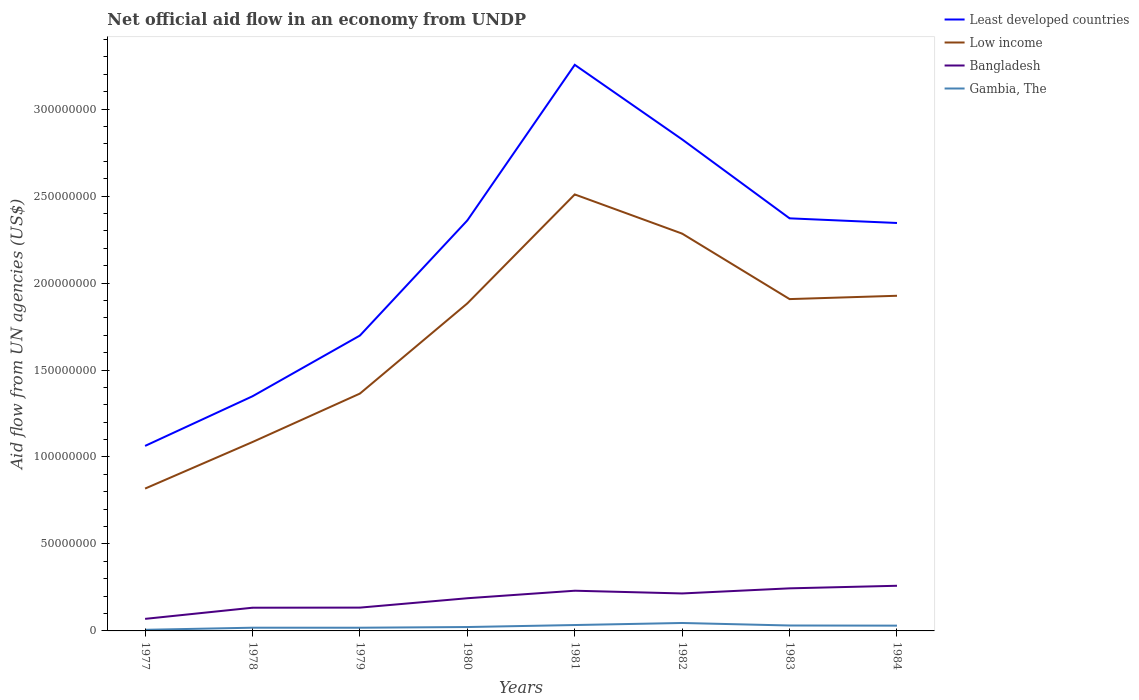Across all years, what is the maximum net official aid flow in Least developed countries?
Make the answer very short. 1.06e+08. What is the total net official aid flow in Least developed countries in the graph?
Ensure brevity in your answer.  -9.96e+07. What is the difference between the highest and the second highest net official aid flow in Gambia, The?
Offer a terse response. 3.92e+06. How many lines are there?
Keep it short and to the point. 4. Are the values on the major ticks of Y-axis written in scientific E-notation?
Your answer should be very brief. No. Does the graph contain grids?
Make the answer very short. No. What is the title of the graph?
Provide a short and direct response. Net official aid flow in an economy from UNDP. What is the label or title of the Y-axis?
Your answer should be compact. Aid flow from UN agencies (US$). What is the Aid flow from UN agencies (US$) in Least developed countries in 1977?
Ensure brevity in your answer.  1.06e+08. What is the Aid flow from UN agencies (US$) of Low income in 1977?
Offer a terse response. 8.18e+07. What is the Aid flow from UN agencies (US$) of Bangladesh in 1977?
Keep it short and to the point. 6.93e+06. What is the Aid flow from UN agencies (US$) of Gambia, The in 1977?
Your response must be concise. 6.40e+05. What is the Aid flow from UN agencies (US$) in Least developed countries in 1978?
Make the answer very short. 1.35e+08. What is the Aid flow from UN agencies (US$) of Low income in 1978?
Provide a short and direct response. 1.09e+08. What is the Aid flow from UN agencies (US$) in Bangladesh in 1978?
Your answer should be very brief. 1.33e+07. What is the Aid flow from UN agencies (US$) of Gambia, The in 1978?
Ensure brevity in your answer.  1.85e+06. What is the Aid flow from UN agencies (US$) in Least developed countries in 1979?
Offer a very short reply. 1.70e+08. What is the Aid flow from UN agencies (US$) of Low income in 1979?
Provide a short and direct response. 1.36e+08. What is the Aid flow from UN agencies (US$) in Bangladesh in 1979?
Your answer should be very brief. 1.34e+07. What is the Aid flow from UN agencies (US$) in Gambia, The in 1979?
Make the answer very short. 1.84e+06. What is the Aid flow from UN agencies (US$) in Least developed countries in 1980?
Provide a succinct answer. 2.36e+08. What is the Aid flow from UN agencies (US$) in Low income in 1980?
Your answer should be compact. 1.88e+08. What is the Aid flow from UN agencies (US$) of Bangladesh in 1980?
Give a very brief answer. 1.88e+07. What is the Aid flow from UN agencies (US$) in Gambia, The in 1980?
Your answer should be compact. 2.24e+06. What is the Aid flow from UN agencies (US$) of Least developed countries in 1981?
Keep it short and to the point. 3.25e+08. What is the Aid flow from UN agencies (US$) in Low income in 1981?
Your answer should be compact. 2.51e+08. What is the Aid flow from UN agencies (US$) of Bangladesh in 1981?
Make the answer very short. 2.31e+07. What is the Aid flow from UN agencies (US$) in Gambia, The in 1981?
Provide a succinct answer. 3.39e+06. What is the Aid flow from UN agencies (US$) of Least developed countries in 1982?
Keep it short and to the point. 2.83e+08. What is the Aid flow from UN agencies (US$) in Low income in 1982?
Offer a terse response. 2.28e+08. What is the Aid flow from UN agencies (US$) of Bangladesh in 1982?
Provide a succinct answer. 2.15e+07. What is the Aid flow from UN agencies (US$) of Gambia, The in 1982?
Make the answer very short. 4.56e+06. What is the Aid flow from UN agencies (US$) of Least developed countries in 1983?
Make the answer very short. 2.37e+08. What is the Aid flow from UN agencies (US$) in Low income in 1983?
Your answer should be compact. 1.91e+08. What is the Aid flow from UN agencies (US$) in Bangladesh in 1983?
Your answer should be very brief. 2.45e+07. What is the Aid flow from UN agencies (US$) of Gambia, The in 1983?
Keep it short and to the point. 3.12e+06. What is the Aid flow from UN agencies (US$) of Least developed countries in 1984?
Offer a terse response. 2.35e+08. What is the Aid flow from UN agencies (US$) in Low income in 1984?
Ensure brevity in your answer.  1.93e+08. What is the Aid flow from UN agencies (US$) of Bangladesh in 1984?
Your response must be concise. 2.60e+07. What is the Aid flow from UN agencies (US$) of Gambia, The in 1984?
Your response must be concise. 3.04e+06. Across all years, what is the maximum Aid flow from UN agencies (US$) of Least developed countries?
Offer a very short reply. 3.25e+08. Across all years, what is the maximum Aid flow from UN agencies (US$) in Low income?
Keep it short and to the point. 2.51e+08. Across all years, what is the maximum Aid flow from UN agencies (US$) in Bangladesh?
Give a very brief answer. 2.60e+07. Across all years, what is the maximum Aid flow from UN agencies (US$) of Gambia, The?
Ensure brevity in your answer.  4.56e+06. Across all years, what is the minimum Aid flow from UN agencies (US$) in Least developed countries?
Provide a short and direct response. 1.06e+08. Across all years, what is the minimum Aid flow from UN agencies (US$) in Low income?
Keep it short and to the point. 8.18e+07. Across all years, what is the minimum Aid flow from UN agencies (US$) of Bangladesh?
Offer a terse response. 6.93e+06. Across all years, what is the minimum Aid flow from UN agencies (US$) of Gambia, The?
Provide a succinct answer. 6.40e+05. What is the total Aid flow from UN agencies (US$) in Least developed countries in the graph?
Give a very brief answer. 1.73e+09. What is the total Aid flow from UN agencies (US$) in Low income in the graph?
Your answer should be compact. 1.38e+09. What is the total Aid flow from UN agencies (US$) of Bangladesh in the graph?
Your answer should be very brief. 1.48e+08. What is the total Aid flow from UN agencies (US$) of Gambia, The in the graph?
Keep it short and to the point. 2.07e+07. What is the difference between the Aid flow from UN agencies (US$) in Least developed countries in 1977 and that in 1978?
Make the answer very short. -2.85e+07. What is the difference between the Aid flow from UN agencies (US$) in Low income in 1977 and that in 1978?
Offer a terse response. -2.68e+07. What is the difference between the Aid flow from UN agencies (US$) in Bangladesh in 1977 and that in 1978?
Provide a short and direct response. -6.41e+06. What is the difference between the Aid flow from UN agencies (US$) in Gambia, The in 1977 and that in 1978?
Provide a succinct answer. -1.21e+06. What is the difference between the Aid flow from UN agencies (US$) of Least developed countries in 1977 and that in 1979?
Keep it short and to the point. -6.34e+07. What is the difference between the Aid flow from UN agencies (US$) in Low income in 1977 and that in 1979?
Provide a short and direct response. -5.46e+07. What is the difference between the Aid flow from UN agencies (US$) in Bangladesh in 1977 and that in 1979?
Give a very brief answer. -6.47e+06. What is the difference between the Aid flow from UN agencies (US$) in Gambia, The in 1977 and that in 1979?
Give a very brief answer. -1.20e+06. What is the difference between the Aid flow from UN agencies (US$) of Least developed countries in 1977 and that in 1980?
Your response must be concise. -1.30e+08. What is the difference between the Aid flow from UN agencies (US$) in Low income in 1977 and that in 1980?
Give a very brief answer. -1.06e+08. What is the difference between the Aid flow from UN agencies (US$) of Bangladesh in 1977 and that in 1980?
Keep it short and to the point. -1.19e+07. What is the difference between the Aid flow from UN agencies (US$) in Gambia, The in 1977 and that in 1980?
Provide a succinct answer. -1.60e+06. What is the difference between the Aid flow from UN agencies (US$) of Least developed countries in 1977 and that in 1981?
Provide a succinct answer. -2.19e+08. What is the difference between the Aid flow from UN agencies (US$) in Low income in 1977 and that in 1981?
Make the answer very short. -1.69e+08. What is the difference between the Aid flow from UN agencies (US$) of Bangladesh in 1977 and that in 1981?
Your answer should be compact. -1.62e+07. What is the difference between the Aid flow from UN agencies (US$) in Gambia, The in 1977 and that in 1981?
Ensure brevity in your answer.  -2.75e+06. What is the difference between the Aid flow from UN agencies (US$) in Least developed countries in 1977 and that in 1982?
Provide a succinct answer. -1.76e+08. What is the difference between the Aid flow from UN agencies (US$) in Low income in 1977 and that in 1982?
Offer a very short reply. -1.47e+08. What is the difference between the Aid flow from UN agencies (US$) in Bangladesh in 1977 and that in 1982?
Offer a very short reply. -1.46e+07. What is the difference between the Aid flow from UN agencies (US$) in Gambia, The in 1977 and that in 1982?
Offer a very short reply. -3.92e+06. What is the difference between the Aid flow from UN agencies (US$) of Least developed countries in 1977 and that in 1983?
Provide a short and direct response. -1.31e+08. What is the difference between the Aid flow from UN agencies (US$) of Low income in 1977 and that in 1983?
Provide a short and direct response. -1.09e+08. What is the difference between the Aid flow from UN agencies (US$) of Bangladesh in 1977 and that in 1983?
Keep it short and to the point. -1.76e+07. What is the difference between the Aid flow from UN agencies (US$) in Gambia, The in 1977 and that in 1983?
Give a very brief answer. -2.48e+06. What is the difference between the Aid flow from UN agencies (US$) in Least developed countries in 1977 and that in 1984?
Make the answer very short. -1.28e+08. What is the difference between the Aid flow from UN agencies (US$) of Low income in 1977 and that in 1984?
Provide a short and direct response. -1.11e+08. What is the difference between the Aid flow from UN agencies (US$) in Bangladesh in 1977 and that in 1984?
Your response must be concise. -1.90e+07. What is the difference between the Aid flow from UN agencies (US$) of Gambia, The in 1977 and that in 1984?
Offer a very short reply. -2.40e+06. What is the difference between the Aid flow from UN agencies (US$) in Least developed countries in 1978 and that in 1979?
Provide a short and direct response. -3.49e+07. What is the difference between the Aid flow from UN agencies (US$) in Low income in 1978 and that in 1979?
Give a very brief answer. -2.78e+07. What is the difference between the Aid flow from UN agencies (US$) of Least developed countries in 1978 and that in 1980?
Ensure brevity in your answer.  -1.01e+08. What is the difference between the Aid flow from UN agencies (US$) of Low income in 1978 and that in 1980?
Provide a succinct answer. -7.97e+07. What is the difference between the Aid flow from UN agencies (US$) of Bangladesh in 1978 and that in 1980?
Give a very brief answer. -5.45e+06. What is the difference between the Aid flow from UN agencies (US$) of Gambia, The in 1978 and that in 1980?
Provide a succinct answer. -3.90e+05. What is the difference between the Aid flow from UN agencies (US$) of Least developed countries in 1978 and that in 1981?
Provide a short and direct response. -1.91e+08. What is the difference between the Aid flow from UN agencies (US$) of Low income in 1978 and that in 1981?
Keep it short and to the point. -1.42e+08. What is the difference between the Aid flow from UN agencies (US$) in Bangladesh in 1978 and that in 1981?
Give a very brief answer. -9.77e+06. What is the difference between the Aid flow from UN agencies (US$) in Gambia, The in 1978 and that in 1981?
Ensure brevity in your answer.  -1.54e+06. What is the difference between the Aid flow from UN agencies (US$) in Least developed countries in 1978 and that in 1982?
Ensure brevity in your answer.  -1.48e+08. What is the difference between the Aid flow from UN agencies (US$) in Low income in 1978 and that in 1982?
Offer a very short reply. -1.20e+08. What is the difference between the Aid flow from UN agencies (US$) of Bangladesh in 1978 and that in 1982?
Offer a very short reply. -8.20e+06. What is the difference between the Aid flow from UN agencies (US$) of Gambia, The in 1978 and that in 1982?
Your answer should be very brief. -2.71e+06. What is the difference between the Aid flow from UN agencies (US$) in Least developed countries in 1978 and that in 1983?
Your answer should be compact. -1.02e+08. What is the difference between the Aid flow from UN agencies (US$) in Low income in 1978 and that in 1983?
Provide a short and direct response. -8.22e+07. What is the difference between the Aid flow from UN agencies (US$) of Bangladesh in 1978 and that in 1983?
Make the answer very short. -1.11e+07. What is the difference between the Aid flow from UN agencies (US$) of Gambia, The in 1978 and that in 1983?
Give a very brief answer. -1.27e+06. What is the difference between the Aid flow from UN agencies (US$) of Least developed countries in 1978 and that in 1984?
Make the answer very short. -9.96e+07. What is the difference between the Aid flow from UN agencies (US$) in Low income in 1978 and that in 1984?
Make the answer very short. -8.41e+07. What is the difference between the Aid flow from UN agencies (US$) in Bangladesh in 1978 and that in 1984?
Your answer should be compact. -1.26e+07. What is the difference between the Aid flow from UN agencies (US$) of Gambia, The in 1978 and that in 1984?
Your answer should be very brief. -1.19e+06. What is the difference between the Aid flow from UN agencies (US$) of Least developed countries in 1979 and that in 1980?
Your answer should be very brief. -6.62e+07. What is the difference between the Aid flow from UN agencies (US$) in Low income in 1979 and that in 1980?
Give a very brief answer. -5.18e+07. What is the difference between the Aid flow from UN agencies (US$) in Bangladesh in 1979 and that in 1980?
Make the answer very short. -5.39e+06. What is the difference between the Aid flow from UN agencies (US$) of Gambia, The in 1979 and that in 1980?
Offer a very short reply. -4.00e+05. What is the difference between the Aid flow from UN agencies (US$) in Least developed countries in 1979 and that in 1981?
Your answer should be very brief. -1.56e+08. What is the difference between the Aid flow from UN agencies (US$) in Low income in 1979 and that in 1981?
Keep it short and to the point. -1.14e+08. What is the difference between the Aid flow from UN agencies (US$) of Bangladesh in 1979 and that in 1981?
Make the answer very short. -9.71e+06. What is the difference between the Aid flow from UN agencies (US$) in Gambia, The in 1979 and that in 1981?
Offer a terse response. -1.55e+06. What is the difference between the Aid flow from UN agencies (US$) of Least developed countries in 1979 and that in 1982?
Your answer should be very brief. -1.13e+08. What is the difference between the Aid flow from UN agencies (US$) of Low income in 1979 and that in 1982?
Provide a succinct answer. -9.20e+07. What is the difference between the Aid flow from UN agencies (US$) in Bangladesh in 1979 and that in 1982?
Your answer should be compact. -8.14e+06. What is the difference between the Aid flow from UN agencies (US$) of Gambia, The in 1979 and that in 1982?
Ensure brevity in your answer.  -2.72e+06. What is the difference between the Aid flow from UN agencies (US$) in Least developed countries in 1979 and that in 1983?
Make the answer very short. -6.74e+07. What is the difference between the Aid flow from UN agencies (US$) of Low income in 1979 and that in 1983?
Make the answer very short. -5.43e+07. What is the difference between the Aid flow from UN agencies (US$) of Bangladesh in 1979 and that in 1983?
Ensure brevity in your answer.  -1.11e+07. What is the difference between the Aid flow from UN agencies (US$) in Gambia, The in 1979 and that in 1983?
Ensure brevity in your answer.  -1.28e+06. What is the difference between the Aid flow from UN agencies (US$) in Least developed countries in 1979 and that in 1984?
Your answer should be compact. -6.47e+07. What is the difference between the Aid flow from UN agencies (US$) in Low income in 1979 and that in 1984?
Provide a short and direct response. -5.62e+07. What is the difference between the Aid flow from UN agencies (US$) of Bangladesh in 1979 and that in 1984?
Offer a terse response. -1.26e+07. What is the difference between the Aid flow from UN agencies (US$) of Gambia, The in 1979 and that in 1984?
Offer a terse response. -1.20e+06. What is the difference between the Aid flow from UN agencies (US$) of Least developed countries in 1980 and that in 1981?
Offer a terse response. -8.95e+07. What is the difference between the Aid flow from UN agencies (US$) in Low income in 1980 and that in 1981?
Your answer should be very brief. -6.26e+07. What is the difference between the Aid flow from UN agencies (US$) in Bangladesh in 1980 and that in 1981?
Your answer should be compact. -4.32e+06. What is the difference between the Aid flow from UN agencies (US$) of Gambia, The in 1980 and that in 1981?
Provide a succinct answer. -1.15e+06. What is the difference between the Aid flow from UN agencies (US$) of Least developed countries in 1980 and that in 1982?
Make the answer very short. -4.66e+07. What is the difference between the Aid flow from UN agencies (US$) of Low income in 1980 and that in 1982?
Offer a terse response. -4.01e+07. What is the difference between the Aid flow from UN agencies (US$) of Bangladesh in 1980 and that in 1982?
Make the answer very short. -2.75e+06. What is the difference between the Aid flow from UN agencies (US$) of Gambia, The in 1980 and that in 1982?
Keep it short and to the point. -2.32e+06. What is the difference between the Aid flow from UN agencies (US$) of Least developed countries in 1980 and that in 1983?
Ensure brevity in your answer.  -1.20e+06. What is the difference between the Aid flow from UN agencies (US$) in Low income in 1980 and that in 1983?
Ensure brevity in your answer.  -2.47e+06. What is the difference between the Aid flow from UN agencies (US$) of Bangladesh in 1980 and that in 1983?
Your answer should be very brief. -5.69e+06. What is the difference between the Aid flow from UN agencies (US$) in Gambia, The in 1980 and that in 1983?
Your response must be concise. -8.80e+05. What is the difference between the Aid flow from UN agencies (US$) in Least developed countries in 1980 and that in 1984?
Offer a terse response. 1.47e+06. What is the difference between the Aid flow from UN agencies (US$) in Low income in 1980 and that in 1984?
Your response must be concise. -4.38e+06. What is the difference between the Aid flow from UN agencies (US$) in Bangladesh in 1980 and that in 1984?
Offer a very short reply. -7.17e+06. What is the difference between the Aid flow from UN agencies (US$) in Gambia, The in 1980 and that in 1984?
Your answer should be very brief. -8.00e+05. What is the difference between the Aid flow from UN agencies (US$) of Least developed countries in 1981 and that in 1982?
Provide a succinct answer. 4.29e+07. What is the difference between the Aid flow from UN agencies (US$) in Low income in 1981 and that in 1982?
Keep it short and to the point. 2.25e+07. What is the difference between the Aid flow from UN agencies (US$) in Bangladesh in 1981 and that in 1982?
Provide a succinct answer. 1.57e+06. What is the difference between the Aid flow from UN agencies (US$) in Gambia, The in 1981 and that in 1982?
Offer a very short reply. -1.17e+06. What is the difference between the Aid flow from UN agencies (US$) in Least developed countries in 1981 and that in 1983?
Provide a succinct answer. 8.83e+07. What is the difference between the Aid flow from UN agencies (US$) of Low income in 1981 and that in 1983?
Your response must be concise. 6.02e+07. What is the difference between the Aid flow from UN agencies (US$) in Bangladesh in 1981 and that in 1983?
Offer a terse response. -1.37e+06. What is the difference between the Aid flow from UN agencies (US$) of Gambia, The in 1981 and that in 1983?
Keep it short and to the point. 2.70e+05. What is the difference between the Aid flow from UN agencies (US$) of Least developed countries in 1981 and that in 1984?
Your response must be concise. 9.09e+07. What is the difference between the Aid flow from UN agencies (US$) of Low income in 1981 and that in 1984?
Keep it short and to the point. 5.83e+07. What is the difference between the Aid flow from UN agencies (US$) in Bangladesh in 1981 and that in 1984?
Provide a short and direct response. -2.85e+06. What is the difference between the Aid flow from UN agencies (US$) of Gambia, The in 1981 and that in 1984?
Give a very brief answer. 3.50e+05. What is the difference between the Aid flow from UN agencies (US$) of Least developed countries in 1982 and that in 1983?
Offer a very short reply. 4.54e+07. What is the difference between the Aid flow from UN agencies (US$) of Low income in 1982 and that in 1983?
Make the answer very short. 3.76e+07. What is the difference between the Aid flow from UN agencies (US$) of Bangladesh in 1982 and that in 1983?
Make the answer very short. -2.94e+06. What is the difference between the Aid flow from UN agencies (US$) of Gambia, The in 1982 and that in 1983?
Your answer should be very brief. 1.44e+06. What is the difference between the Aid flow from UN agencies (US$) of Least developed countries in 1982 and that in 1984?
Your answer should be compact. 4.80e+07. What is the difference between the Aid flow from UN agencies (US$) in Low income in 1982 and that in 1984?
Keep it short and to the point. 3.57e+07. What is the difference between the Aid flow from UN agencies (US$) in Bangladesh in 1982 and that in 1984?
Your answer should be very brief. -4.42e+06. What is the difference between the Aid flow from UN agencies (US$) of Gambia, The in 1982 and that in 1984?
Ensure brevity in your answer.  1.52e+06. What is the difference between the Aid flow from UN agencies (US$) in Least developed countries in 1983 and that in 1984?
Keep it short and to the point. 2.67e+06. What is the difference between the Aid flow from UN agencies (US$) in Low income in 1983 and that in 1984?
Give a very brief answer. -1.91e+06. What is the difference between the Aid flow from UN agencies (US$) of Bangladesh in 1983 and that in 1984?
Make the answer very short. -1.48e+06. What is the difference between the Aid flow from UN agencies (US$) of Least developed countries in 1977 and the Aid flow from UN agencies (US$) of Low income in 1978?
Your response must be concise. -2.24e+06. What is the difference between the Aid flow from UN agencies (US$) in Least developed countries in 1977 and the Aid flow from UN agencies (US$) in Bangladesh in 1978?
Offer a terse response. 9.30e+07. What is the difference between the Aid flow from UN agencies (US$) of Least developed countries in 1977 and the Aid flow from UN agencies (US$) of Gambia, The in 1978?
Offer a very short reply. 1.05e+08. What is the difference between the Aid flow from UN agencies (US$) in Low income in 1977 and the Aid flow from UN agencies (US$) in Bangladesh in 1978?
Offer a terse response. 6.85e+07. What is the difference between the Aid flow from UN agencies (US$) in Low income in 1977 and the Aid flow from UN agencies (US$) in Gambia, The in 1978?
Ensure brevity in your answer.  8.00e+07. What is the difference between the Aid flow from UN agencies (US$) of Bangladesh in 1977 and the Aid flow from UN agencies (US$) of Gambia, The in 1978?
Your response must be concise. 5.08e+06. What is the difference between the Aid flow from UN agencies (US$) of Least developed countries in 1977 and the Aid flow from UN agencies (US$) of Low income in 1979?
Give a very brief answer. -3.01e+07. What is the difference between the Aid flow from UN agencies (US$) in Least developed countries in 1977 and the Aid flow from UN agencies (US$) in Bangladesh in 1979?
Keep it short and to the point. 9.30e+07. What is the difference between the Aid flow from UN agencies (US$) in Least developed countries in 1977 and the Aid flow from UN agencies (US$) in Gambia, The in 1979?
Your answer should be compact. 1.05e+08. What is the difference between the Aid flow from UN agencies (US$) of Low income in 1977 and the Aid flow from UN agencies (US$) of Bangladesh in 1979?
Give a very brief answer. 6.84e+07. What is the difference between the Aid flow from UN agencies (US$) of Low income in 1977 and the Aid flow from UN agencies (US$) of Gambia, The in 1979?
Make the answer very short. 8.00e+07. What is the difference between the Aid flow from UN agencies (US$) in Bangladesh in 1977 and the Aid flow from UN agencies (US$) in Gambia, The in 1979?
Your answer should be very brief. 5.09e+06. What is the difference between the Aid flow from UN agencies (US$) of Least developed countries in 1977 and the Aid flow from UN agencies (US$) of Low income in 1980?
Your response must be concise. -8.19e+07. What is the difference between the Aid flow from UN agencies (US$) in Least developed countries in 1977 and the Aid flow from UN agencies (US$) in Bangladesh in 1980?
Offer a very short reply. 8.76e+07. What is the difference between the Aid flow from UN agencies (US$) in Least developed countries in 1977 and the Aid flow from UN agencies (US$) in Gambia, The in 1980?
Make the answer very short. 1.04e+08. What is the difference between the Aid flow from UN agencies (US$) of Low income in 1977 and the Aid flow from UN agencies (US$) of Bangladesh in 1980?
Give a very brief answer. 6.30e+07. What is the difference between the Aid flow from UN agencies (US$) of Low income in 1977 and the Aid flow from UN agencies (US$) of Gambia, The in 1980?
Give a very brief answer. 7.96e+07. What is the difference between the Aid flow from UN agencies (US$) of Bangladesh in 1977 and the Aid flow from UN agencies (US$) of Gambia, The in 1980?
Offer a very short reply. 4.69e+06. What is the difference between the Aid flow from UN agencies (US$) in Least developed countries in 1977 and the Aid flow from UN agencies (US$) in Low income in 1981?
Your answer should be very brief. -1.45e+08. What is the difference between the Aid flow from UN agencies (US$) in Least developed countries in 1977 and the Aid flow from UN agencies (US$) in Bangladesh in 1981?
Provide a short and direct response. 8.33e+07. What is the difference between the Aid flow from UN agencies (US$) in Least developed countries in 1977 and the Aid flow from UN agencies (US$) in Gambia, The in 1981?
Your response must be concise. 1.03e+08. What is the difference between the Aid flow from UN agencies (US$) in Low income in 1977 and the Aid flow from UN agencies (US$) in Bangladesh in 1981?
Ensure brevity in your answer.  5.87e+07. What is the difference between the Aid flow from UN agencies (US$) of Low income in 1977 and the Aid flow from UN agencies (US$) of Gambia, The in 1981?
Provide a short and direct response. 7.84e+07. What is the difference between the Aid flow from UN agencies (US$) of Bangladesh in 1977 and the Aid flow from UN agencies (US$) of Gambia, The in 1981?
Make the answer very short. 3.54e+06. What is the difference between the Aid flow from UN agencies (US$) in Least developed countries in 1977 and the Aid flow from UN agencies (US$) in Low income in 1982?
Offer a very short reply. -1.22e+08. What is the difference between the Aid flow from UN agencies (US$) in Least developed countries in 1977 and the Aid flow from UN agencies (US$) in Bangladesh in 1982?
Your answer should be compact. 8.48e+07. What is the difference between the Aid flow from UN agencies (US$) of Least developed countries in 1977 and the Aid flow from UN agencies (US$) of Gambia, The in 1982?
Keep it short and to the point. 1.02e+08. What is the difference between the Aid flow from UN agencies (US$) of Low income in 1977 and the Aid flow from UN agencies (US$) of Bangladesh in 1982?
Provide a short and direct response. 6.03e+07. What is the difference between the Aid flow from UN agencies (US$) in Low income in 1977 and the Aid flow from UN agencies (US$) in Gambia, The in 1982?
Ensure brevity in your answer.  7.73e+07. What is the difference between the Aid flow from UN agencies (US$) in Bangladesh in 1977 and the Aid flow from UN agencies (US$) in Gambia, The in 1982?
Offer a very short reply. 2.37e+06. What is the difference between the Aid flow from UN agencies (US$) of Least developed countries in 1977 and the Aid flow from UN agencies (US$) of Low income in 1983?
Your response must be concise. -8.44e+07. What is the difference between the Aid flow from UN agencies (US$) of Least developed countries in 1977 and the Aid flow from UN agencies (US$) of Bangladesh in 1983?
Offer a very short reply. 8.19e+07. What is the difference between the Aid flow from UN agencies (US$) in Least developed countries in 1977 and the Aid flow from UN agencies (US$) in Gambia, The in 1983?
Ensure brevity in your answer.  1.03e+08. What is the difference between the Aid flow from UN agencies (US$) in Low income in 1977 and the Aid flow from UN agencies (US$) in Bangladesh in 1983?
Offer a very short reply. 5.74e+07. What is the difference between the Aid flow from UN agencies (US$) in Low income in 1977 and the Aid flow from UN agencies (US$) in Gambia, The in 1983?
Offer a terse response. 7.87e+07. What is the difference between the Aid flow from UN agencies (US$) in Bangladesh in 1977 and the Aid flow from UN agencies (US$) in Gambia, The in 1983?
Your answer should be very brief. 3.81e+06. What is the difference between the Aid flow from UN agencies (US$) in Least developed countries in 1977 and the Aid flow from UN agencies (US$) in Low income in 1984?
Your answer should be very brief. -8.63e+07. What is the difference between the Aid flow from UN agencies (US$) of Least developed countries in 1977 and the Aid flow from UN agencies (US$) of Bangladesh in 1984?
Offer a very short reply. 8.04e+07. What is the difference between the Aid flow from UN agencies (US$) in Least developed countries in 1977 and the Aid flow from UN agencies (US$) in Gambia, The in 1984?
Make the answer very short. 1.03e+08. What is the difference between the Aid flow from UN agencies (US$) of Low income in 1977 and the Aid flow from UN agencies (US$) of Bangladesh in 1984?
Offer a very short reply. 5.59e+07. What is the difference between the Aid flow from UN agencies (US$) of Low income in 1977 and the Aid flow from UN agencies (US$) of Gambia, The in 1984?
Offer a terse response. 7.88e+07. What is the difference between the Aid flow from UN agencies (US$) in Bangladesh in 1977 and the Aid flow from UN agencies (US$) in Gambia, The in 1984?
Your answer should be very brief. 3.89e+06. What is the difference between the Aid flow from UN agencies (US$) of Least developed countries in 1978 and the Aid flow from UN agencies (US$) of Low income in 1979?
Your answer should be compact. -1.55e+06. What is the difference between the Aid flow from UN agencies (US$) in Least developed countries in 1978 and the Aid flow from UN agencies (US$) in Bangladesh in 1979?
Give a very brief answer. 1.22e+08. What is the difference between the Aid flow from UN agencies (US$) of Least developed countries in 1978 and the Aid flow from UN agencies (US$) of Gambia, The in 1979?
Provide a short and direct response. 1.33e+08. What is the difference between the Aid flow from UN agencies (US$) in Low income in 1978 and the Aid flow from UN agencies (US$) in Bangladesh in 1979?
Provide a succinct answer. 9.52e+07. What is the difference between the Aid flow from UN agencies (US$) of Low income in 1978 and the Aid flow from UN agencies (US$) of Gambia, The in 1979?
Ensure brevity in your answer.  1.07e+08. What is the difference between the Aid flow from UN agencies (US$) of Bangladesh in 1978 and the Aid flow from UN agencies (US$) of Gambia, The in 1979?
Offer a very short reply. 1.15e+07. What is the difference between the Aid flow from UN agencies (US$) of Least developed countries in 1978 and the Aid flow from UN agencies (US$) of Low income in 1980?
Give a very brief answer. -5.34e+07. What is the difference between the Aid flow from UN agencies (US$) in Least developed countries in 1978 and the Aid flow from UN agencies (US$) in Bangladesh in 1980?
Your answer should be compact. 1.16e+08. What is the difference between the Aid flow from UN agencies (US$) in Least developed countries in 1978 and the Aid flow from UN agencies (US$) in Gambia, The in 1980?
Make the answer very short. 1.33e+08. What is the difference between the Aid flow from UN agencies (US$) of Low income in 1978 and the Aid flow from UN agencies (US$) of Bangladesh in 1980?
Give a very brief answer. 8.98e+07. What is the difference between the Aid flow from UN agencies (US$) of Low income in 1978 and the Aid flow from UN agencies (US$) of Gambia, The in 1980?
Your response must be concise. 1.06e+08. What is the difference between the Aid flow from UN agencies (US$) of Bangladesh in 1978 and the Aid flow from UN agencies (US$) of Gambia, The in 1980?
Your answer should be compact. 1.11e+07. What is the difference between the Aid flow from UN agencies (US$) of Least developed countries in 1978 and the Aid flow from UN agencies (US$) of Low income in 1981?
Offer a very short reply. -1.16e+08. What is the difference between the Aid flow from UN agencies (US$) of Least developed countries in 1978 and the Aid flow from UN agencies (US$) of Bangladesh in 1981?
Offer a terse response. 1.12e+08. What is the difference between the Aid flow from UN agencies (US$) of Least developed countries in 1978 and the Aid flow from UN agencies (US$) of Gambia, The in 1981?
Your answer should be very brief. 1.32e+08. What is the difference between the Aid flow from UN agencies (US$) of Low income in 1978 and the Aid flow from UN agencies (US$) of Bangladesh in 1981?
Make the answer very short. 8.55e+07. What is the difference between the Aid flow from UN agencies (US$) of Low income in 1978 and the Aid flow from UN agencies (US$) of Gambia, The in 1981?
Your answer should be compact. 1.05e+08. What is the difference between the Aid flow from UN agencies (US$) in Bangladesh in 1978 and the Aid flow from UN agencies (US$) in Gambia, The in 1981?
Ensure brevity in your answer.  9.95e+06. What is the difference between the Aid flow from UN agencies (US$) in Least developed countries in 1978 and the Aid flow from UN agencies (US$) in Low income in 1982?
Ensure brevity in your answer.  -9.35e+07. What is the difference between the Aid flow from UN agencies (US$) of Least developed countries in 1978 and the Aid flow from UN agencies (US$) of Bangladesh in 1982?
Offer a very short reply. 1.13e+08. What is the difference between the Aid flow from UN agencies (US$) of Least developed countries in 1978 and the Aid flow from UN agencies (US$) of Gambia, The in 1982?
Provide a succinct answer. 1.30e+08. What is the difference between the Aid flow from UN agencies (US$) in Low income in 1978 and the Aid flow from UN agencies (US$) in Bangladesh in 1982?
Your response must be concise. 8.71e+07. What is the difference between the Aid flow from UN agencies (US$) of Low income in 1978 and the Aid flow from UN agencies (US$) of Gambia, The in 1982?
Offer a terse response. 1.04e+08. What is the difference between the Aid flow from UN agencies (US$) in Bangladesh in 1978 and the Aid flow from UN agencies (US$) in Gambia, The in 1982?
Provide a short and direct response. 8.78e+06. What is the difference between the Aid flow from UN agencies (US$) of Least developed countries in 1978 and the Aid flow from UN agencies (US$) of Low income in 1983?
Provide a succinct answer. -5.59e+07. What is the difference between the Aid flow from UN agencies (US$) of Least developed countries in 1978 and the Aid flow from UN agencies (US$) of Bangladesh in 1983?
Offer a very short reply. 1.10e+08. What is the difference between the Aid flow from UN agencies (US$) in Least developed countries in 1978 and the Aid flow from UN agencies (US$) in Gambia, The in 1983?
Your answer should be very brief. 1.32e+08. What is the difference between the Aid flow from UN agencies (US$) of Low income in 1978 and the Aid flow from UN agencies (US$) of Bangladesh in 1983?
Keep it short and to the point. 8.41e+07. What is the difference between the Aid flow from UN agencies (US$) of Low income in 1978 and the Aid flow from UN agencies (US$) of Gambia, The in 1983?
Provide a succinct answer. 1.05e+08. What is the difference between the Aid flow from UN agencies (US$) of Bangladesh in 1978 and the Aid flow from UN agencies (US$) of Gambia, The in 1983?
Offer a very short reply. 1.02e+07. What is the difference between the Aid flow from UN agencies (US$) in Least developed countries in 1978 and the Aid flow from UN agencies (US$) in Low income in 1984?
Keep it short and to the point. -5.78e+07. What is the difference between the Aid flow from UN agencies (US$) in Least developed countries in 1978 and the Aid flow from UN agencies (US$) in Bangladesh in 1984?
Provide a short and direct response. 1.09e+08. What is the difference between the Aid flow from UN agencies (US$) in Least developed countries in 1978 and the Aid flow from UN agencies (US$) in Gambia, The in 1984?
Your answer should be very brief. 1.32e+08. What is the difference between the Aid flow from UN agencies (US$) in Low income in 1978 and the Aid flow from UN agencies (US$) in Bangladesh in 1984?
Your answer should be very brief. 8.26e+07. What is the difference between the Aid flow from UN agencies (US$) in Low income in 1978 and the Aid flow from UN agencies (US$) in Gambia, The in 1984?
Your answer should be compact. 1.06e+08. What is the difference between the Aid flow from UN agencies (US$) of Bangladesh in 1978 and the Aid flow from UN agencies (US$) of Gambia, The in 1984?
Your answer should be very brief. 1.03e+07. What is the difference between the Aid flow from UN agencies (US$) in Least developed countries in 1979 and the Aid flow from UN agencies (US$) in Low income in 1980?
Give a very brief answer. -1.85e+07. What is the difference between the Aid flow from UN agencies (US$) in Least developed countries in 1979 and the Aid flow from UN agencies (US$) in Bangladesh in 1980?
Give a very brief answer. 1.51e+08. What is the difference between the Aid flow from UN agencies (US$) of Least developed countries in 1979 and the Aid flow from UN agencies (US$) of Gambia, The in 1980?
Offer a very short reply. 1.68e+08. What is the difference between the Aid flow from UN agencies (US$) in Low income in 1979 and the Aid flow from UN agencies (US$) in Bangladesh in 1980?
Make the answer very short. 1.18e+08. What is the difference between the Aid flow from UN agencies (US$) in Low income in 1979 and the Aid flow from UN agencies (US$) in Gambia, The in 1980?
Keep it short and to the point. 1.34e+08. What is the difference between the Aid flow from UN agencies (US$) in Bangladesh in 1979 and the Aid flow from UN agencies (US$) in Gambia, The in 1980?
Keep it short and to the point. 1.12e+07. What is the difference between the Aid flow from UN agencies (US$) in Least developed countries in 1979 and the Aid flow from UN agencies (US$) in Low income in 1981?
Provide a succinct answer. -8.11e+07. What is the difference between the Aid flow from UN agencies (US$) in Least developed countries in 1979 and the Aid flow from UN agencies (US$) in Bangladesh in 1981?
Keep it short and to the point. 1.47e+08. What is the difference between the Aid flow from UN agencies (US$) of Least developed countries in 1979 and the Aid flow from UN agencies (US$) of Gambia, The in 1981?
Give a very brief answer. 1.66e+08. What is the difference between the Aid flow from UN agencies (US$) of Low income in 1979 and the Aid flow from UN agencies (US$) of Bangladesh in 1981?
Your response must be concise. 1.13e+08. What is the difference between the Aid flow from UN agencies (US$) in Low income in 1979 and the Aid flow from UN agencies (US$) in Gambia, The in 1981?
Provide a short and direct response. 1.33e+08. What is the difference between the Aid flow from UN agencies (US$) of Bangladesh in 1979 and the Aid flow from UN agencies (US$) of Gambia, The in 1981?
Keep it short and to the point. 1.00e+07. What is the difference between the Aid flow from UN agencies (US$) in Least developed countries in 1979 and the Aid flow from UN agencies (US$) in Low income in 1982?
Your answer should be very brief. -5.86e+07. What is the difference between the Aid flow from UN agencies (US$) in Least developed countries in 1979 and the Aid flow from UN agencies (US$) in Bangladesh in 1982?
Your response must be concise. 1.48e+08. What is the difference between the Aid flow from UN agencies (US$) in Least developed countries in 1979 and the Aid flow from UN agencies (US$) in Gambia, The in 1982?
Ensure brevity in your answer.  1.65e+08. What is the difference between the Aid flow from UN agencies (US$) of Low income in 1979 and the Aid flow from UN agencies (US$) of Bangladesh in 1982?
Your answer should be compact. 1.15e+08. What is the difference between the Aid flow from UN agencies (US$) of Low income in 1979 and the Aid flow from UN agencies (US$) of Gambia, The in 1982?
Offer a very short reply. 1.32e+08. What is the difference between the Aid flow from UN agencies (US$) of Bangladesh in 1979 and the Aid flow from UN agencies (US$) of Gambia, The in 1982?
Offer a terse response. 8.84e+06. What is the difference between the Aid flow from UN agencies (US$) of Least developed countries in 1979 and the Aid flow from UN agencies (US$) of Low income in 1983?
Your response must be concise. -2.10e+07. What is the difference between the Aid flow from UN agencies (US$) in Least developed countries in 1979 and the Aid flow from UN agencies (US$) in Bangladesh in 1983?
Offer a very short reply. 1.45e+08. What is the difference between the Aid flow from UN agencies (US$) of Least developed countries in 1979 and the Aid flow from UN agencies (US$) of Gambia, The in 1983?
Ensure brevity in your answer.  1.67e+08. What is the difference between the Aid flow from UN agencies (US$) in Low income in 1979 and the Aid flow from UN agencies (US$) in Bangladesh in 1983?
Your answer should be compact. 1.12e+08. What is the difference between the Aid flow from UN agencies (US$) of Low income in 1979 and the Aid flow from UN agencies (US$) of Gambia, The in 1983?
Offer a very short reply. 1.33e+08. What is the difference between the Aid flow from UN agencies (US$) of Bangladesh in 1979 and the Aid flow from UN agencies (US$) of Gambia, The in 1983?
Offer a terse response. 1.03e+07. What is the difference between the Aid flow from UN agencies (US$) in Least developed countries in 1979 and the Aid flow from UN agencies (US$) in Low income in 1984?
Keep it short and to the point. -2.29e+07. What is the difference between the Aid flow from UN agencies (US$) of Least developed countries in 1979 and the Aid flow from UN agencies (US$) of Bangladesh in 1984?
Give a very brief answer. 1.44e+08. What is the difference between the Aid flow from UN agencies (US$) in Least developed countries in 1979 and the Aid flow from UN agencies (US$) in Gambia, The in 1984?
Your response must be concise. 1.67e+08. What is the difference between the Aid flow from UN agencies (US$) of Low income in 1979 and the Aid flow from UN agencies (US$) of Bangladesh in 1984?
Your answer should be very brief. 1.10e+08. What is the difference between the Aid flow from UN agencies (US$) of Low income in 1979 and the Aid flow from UN agencies (US$) of Gambia, The in 1984?
Provide a short and direct response. 1.33e+08. What is the difference between the Aid flow from UN agencies (US$) of Bangladesh in 1979 and the Aid flow from UN agencies (US$) of Gambia, The in 1984?
Give a very brief answer. 1.04e+07. What is the difference between the Aid flow from UN agencies (US$) of Least developed countries in 1980 and the Aid flow from UN agencies (US$) of Low income in 1981?
Offer a terse response. -1.49e+07. What is the difference between the Aid flow from UN agencies (US$) of Least developed countries in 1980 and the Aid flow from UN agencies (US$) of Bangladesh in 1981?
Your answer should be compact. 2.13e+08. What is the difference between the Aid flow from UN agencies (US$) of Least developed countries in 1980 and the Aid flow from UN agencies (US$) of Gambia, The in 1981?
Provide a short and direct response. 2.33e+08. What is the difference between the Aid flow from UN agencies (US$) of Low income in 1980 and the Aid flow from UN agencies (US$) of Bangladesh in 1981?
Ensure brevity in your answer.  1.65e+08. What is the difference between the Aid flow from UN agencies (US$) of Low income in 1980 and the Aid flow from UN agencies (US$) of Gambia, The in 1981?
Your response must be concise. 1.85e+08. What is the difference between the Aid flow from UN agencies (US$) of Bangladesh in 1980 and the Aid flow from UN agencies (US$) of Gambia, The in 1981?
Provide a short and direct response. 1.54e+07. What is the difference between the Aid flow from UN agencies (US$) in Least developed countries in 1980 and the Aid flow from UN agencies (US$) in Low income in 1982?
Your answer should be compact. 7.59e+06. What is the difference between the Aid flow from UN agencies (US$) of Least developed countries in 1980 and the Aid flow from UN agencies (US$) of Bangladesh in 1982?
Give a very brief answer. 2.14e+08. What is the difference between the Aid flow from UN agencies (US$) in Least developed countries in 1980 and the Aid flow from UN agencies (US$) in Gambia, The in 1982?
Offer a very short reply. 2.31e+08. What is the difference between the Aid flow from UN agencies (US$) of Low income in 1980 and the Aid flow from UN agencies (US$) of Bangladesh in 1982?
Offer a terse response. 1.67e+08. What is the difference between the Aid flow from UN agencies (US$) in Low income in 1980 and the Aid flow from UN agencies (US$) in Gambia, The in 1982?
Your answer should be very brief. 1.84e+08. What is the difference between the Aid flow from UN agencies (US$) in Bangladesh in 1980 and the Aid flow from UN agencies (US$) in Gambia, The in 1982?
Make the answer very short. 1.42e+07. What is the difference between the Aid flow from UN agencies (US$) of Least developed countries in 1980 and the Aid flow from UN agencies (US$) of Low income in 1983?
Ensure brevity in your answer.  4.52e+07. What is the difference between the Aid flow from UN agencies (US$) of Least developed countries in 1980 and the Aid flow from UN agencies (US$) of Bangladesh in 1983?
Ensure brevity in your answer.  2.12e+08. What is the difference between the Aid flow from UN agencies (US$) of Least developed countries in 1980 and the Aid flow from UN agencies (US$) of Gambia, The in 1983?
Your answer should be very brief. 2.33e+08. What is the difference between the Aid flow from UN agencies (US$) in Low income in 1980 and the Aid flow from UN agencies (US$) in Bangladesh in 1983?
Offer a very short reply. 1.64e+08. What is the difference between the Aid flow from UN agencies (US$) of Low income in 1980 and the Aid flow from UN agencies (US$) of Gambia, The in 1983?
Your response must be concise. 1.85e+08. What is the difference between the Aid flow from UN agencies (US$) in Bangladesh in 1980 and the Aid flow from UN agencies (US$) in Gambia, The in 1983?
Offer a very short reply. 1.57e+07. What is the difference between the Aid flow from UN agencies (US$) in Least developed countries in 1980 and the Aid flow from UN agencies (US$) in Low income in 1984?
Your response must be concise. 4.33e+07. What is the difference between the Aid flow from UN agencies (US$) in Least developed countries in 1980 and the Aid flow from UN agencies (US$) in Bangladesh in 1984?
Provide a short and direct response. 2.10e+08. What is the difference between the Aid flow from UN agencies (US$) of Least developed countries in 1980 and the Aid flow from UN agencies (US$) of Gambia, The in 1984?
Your response must be concise. 2.33e+08. What is the difference between the Aid flow from UN agencies (US$) in Low income in 1980 and the Aid flow from UN agencies (US$) in Bangladesh in 1984?
Offer a very short reply. 1.62e+08. What is the difference between the Aid flow from UN agencies (US$) in Low income in 1980 and the Aid flow from UN agencies (US$) in Gambia, The in 1984?
Offer a terse response. 1.85e+08. What is the difference between the Aid flow from UN agencies (US$) in Bangladesh in 1980 and the Aid flow from UN agencies (US$) in Gambia, The in 1984?
Provide a succinct answer. 1.58e+07. What is the difference between the Aid flow from UN agencies (US$) in Least developed countries in 1981 and the Aid flow from UN agencies (US$) in Low income in 1982?
Give a very brief answer. 9.70e+07. What is the difference between the Aid flow from UN agencies (US$) of Least developed countries in 1981 and the Aid flow from UN agencies (US$) of Bangladesh in 1982?
Keep it short and to the point. 3.04e+08. What is the difference between the Aid flow from UN agencies (US$) in Least developed countries in 1981 and the Aid flow from UN agencies (US$) in Gambia, The in 1982?
Your response must be concise. 3.21e+08. What is the difference between the Aid flow from UN agencies (US$) in Low income in 1981 and the Aid flow from UN agencies (US$) in Bangladesh in 1982?
Offer a terse response. 2.29e+08. What is the difference between the Aid flow from UN agencies (US$) in Low income in 1981 and the Aid flow from UN agencies (US$) in Gambia, The in 1982?
Your answer should be very brief. 2.46e+08. What is the difference between the Aid flow from UN agencies (US$) in Bangladesh in 1981 and the Aid flow from UN agencies (US$) in Gambia, The in 1982?
Your response must be concise. 1.86e+07. What is the difference between the Aid flow from UN agencies (US$) of Least developed countries in 1981 and the Aid flow from UN agencies (US$) of Low income in 1983?
Offer a very short reply. 1.35e+08. What is the difference between the Aid flow from UN agencies (US$) of Least developed countries in 1981 and the Aid flow from UN agencies (US$) of Bangladesh in 1983?
Your response must be concise. 3.01e+08. What is the difference between the Aid flow from UN agencies (US$) of Least developed countries in 1981 and the Aid flow from UN agencies (US$) of Gambia, The in 1983?
Your answer should be very brief. 3.22e+08. What is the difference between the Aid flow from UN agencies (US$) in Low income in 1981 and the Aid flow from UN agencies (US$) in Bangladesh in 1983?
Offer a very short reply. 2.26e+08. What is the difference between the Aid flow from UN agencies (US$) in Low income in 1981 and the Aid flow from UN agencies (US$) in Gambia, The in 1983?
Give a very brief answer. 2.48e+08. What is the difference between the Aid flow from UN agencies (US$) of Bangladesh in 1981 and the Aid flow from UN agencies (US$) of Gambia, The in 1983?
Provide a short and direct response. 2.00e+07. What is the difference between the Aid flow from UN agencies (US$) in Least developed countries in 1981 and the Aid flow from UN agencies (US$) in Low income in 1984?
Your answer should be very brief. 1.33e+08. What is the difference between the Aid flow from UN agencies (US$) in Least developed countries in 1981 and the Aid flow from UN agencies (US$) in Bangladesh in 1984?
Make the answer very short. 3.00e+08. What is the difference between the Aid flow from UN agencies (US$) in Least developed countries in 1981 and the Aid flow from UN agencies (US$) in Gambia, The in 1984?
Keep it short and to the point. 3.22e+08. What is the difference between the Aid flow from UN agencies (US$) in Low income in 1981 and the Aid flow from UN agencies (US$) in Bangladesh in 1984?
Make the answer very short. 2.25e+08. What is the difference between the Aid flow from UN agencies (US$) in Low income in 1981 and the Aid flow from UN agencies (US$) in Gambia, The in 1984?
Give a very brief answer. 2.48e+08. What is the difference between the Aid flow from UN agencies (US$) in Bangladesh in 1981 and the Aid flow from UN agencies (US$) in Gambia, The in 1984?
Your answer should be very brief. 2.01e+07. What is the difference between the Aid flow from UN agencies (US$) in Least developed countries in 1982 and the Aid flow from UN agencies (US$) in Low income in 1983?
Provide a succinct answer. 9.18e+07. What is the difference between the Aid flow from UN agencies (US$) in Least developed countries in 1982 and the Aid flow from UN agencies (US$) in Bangladesh in 1983?
Your response must be concise. 2.58e+08. What is the difference between the Aid flow from UN agencies (US$) in Least developed countries in 1982 and the Aid flow from UN agencies (US$) in Gambia, The in 1983?
Keep it short and to the point. 2.79e+08. What is the difference between the Aid flow from UN agencies (US$) in Low income in 1982 and the Aid flow from UN agencies (US$) in Bangladesh in 1983?
Your answer should be compact. 2.04e+08. What is the difference between the Aid flow from UN agencies (US$) in Low income in 1982 and the Aid flow from UN agencies (US$) in Gambia, The in 1983?
Offer a terse response. 2.25e+08. What is the difference between the Aid flow from UN agencies (US$) in Bangladesh in 1982 and the Aid flow from UN agencies (US$) in Gambia, The in 1983?
Your answer should be compact. 1.84e+07. What is the difference between the Aid flow from UN agencies (US$) of Least developed countries in 1982 and the Aid flow from UN agencies (US$) of Low income in 1984?
Your answer should be compact. 8.99e+07. What is the difference between the Aid flow from UN agencies (US$) of Least developed countries in 1982 and the Aid flow from UN agencies (US$) of Bangladesh in 1984?
Keep it short and to the point. 2.57e+08. What is the difference between the Aid flow from UN agencies (US$) of Least developed countries in 1982 and the Aid flow from UN agencies (US$) of Gambia, The in 1984?
Your answer should be very brief. 2.80e+08. What is the difference between the Aid flow from UN agencies (US$) of Low income in 1982 and the Aid flow from UN agencies (US$) of Bangladesh in 1984?
Ensure brevity in your answer.  2.02e+08. What is the difference between the Aid flow from UN agencies (US$) of Low income in 1982 and the Aid flow from UN agencies (US$) of Gambia, The in 1984?
Make the answer very short. 2.25e+08. What is the difference between the Aid flow from UN agencies (US$) in Bangladesh in 1982 and the Aid flow from UN agencies (US$) in Gambia, The in 1984?
Provide a succinct answer. 1.85e+07. What is the difference between the Aid flow from UN agencies (US$) in Least developed countries in 1983 and the Aid flow from UN agencies (US$) in Low income in 1984?
Your answer should be compact. 4.45e+07. What is the difference between the Aid flow from UN agencies (US$) of Least developed countries in 1983 and the Aid flow from UN agencies (US$) of Bangladesh in 1984?
Your answer should be very brief. 2.11e+08. What is the difference between the Aid flow from UN agencies (US$) of Least developed countries in 1983 and the Aid flow from UN agencies (US$) of Gambia, The in 1984?
Give a very brief answer. 2.34e+08. What is the difference between the Aid flow from UN agencies (US$) of Low income in 1983 and the Aid flow from UN agencies (US$) of Bangladesh in 1984?
Your answer should be compact. 1.65e+08. What is the difference between the Aid flow from UN agencies (US$) of Low income in 1983 and the Aid flow from UN agencies (US$) of Gambia, The in 1984?
Keep it short and to the point. 1.88e+08. What is the difference between the Aid flow from UN agencies (US$) in Bangladesh in 1983 and the Aid flow from UN agencies (US$) in Gambia, The in 1984?
Keep it short and to the point. 2.14e+07. What is the average Aid flow from UN agencies (US$) of Least developed countries per year?
Your response must be concise. 2.16e+08. What is the average Aid flow from UN agencies (US$) in Low income per year?
Ensure brevity in your answer.  1.72e+08. What is the average Aid flow from UN agencies (US$) in Bangladesh per year?
Offer a very short reply. 1.84e+07. What is the average Aid flow from UN agencies (US$) in Gambia, The per year?
Give a very brief answer. 2.58e+06. In the year 1977, what is the difference between the Aid flow from UN agencies (US$) in Least developed countries and Aid flow from UN agencies (US$) in Low income?
Provide a succinct answer. 2.45e+07. In the year 1977, what is the difference between the Aid flow from UN agencies (US$) of Least developed countries and Aid flow from UN agencies (US$) of Bangladesh?
Ensure brevity in your answer.  9.94e+07. In the year 1977, what is the difference between the Aid flow from UN agencies (US$) in Least developed countries and Aid flow from UN agencies (US$) in Gambia, The?
Give a very brief answer. 1.06e+08. In the year 1977, what is the difference between the Aid flow from UN agencies (US$) of Low income and Aid flow from UN agencies (US$) of Bangladesh?
Provide a short and direct response. 7.49e+07. In the year 1977, what is the difference between the Aid flow from UN agencies (US$) of Low income and Aid flow from UN agencies (US$) of Gambia, The?
Your answer should be very brief. 8.12e+07. In the year 1977, what is the difference between the Aid flow from UN agencies (US$) in Bangladesh and Aid flow from UN agencies (US$) in Gambia, The?
Your answer should be very brief. 6.29e+06. In the year 1978, what is the difference between the Aid flow from UN agencies (US$) in Least developed countries and Aid flow from UN agencies (US$) in Low income?
Make the answer very short. 2.63e+07. In the year 1978, what is the difference between the Aid flow from UN agencies (US$) of Least developed countries and Aid flow from UN agencies (US$) of Bangladesh?
Make the answer very short. 1.22e+08. In the year 1978, what is the difference between the Aid flow from UN agencies (US$) of Least developed countries and Aid flow from UN agencies (US$) of Gambia, The?
Provide a succinct answer. 1.33e+08. In the year 1978, what is the difference between the Aid flow from UN agencies (US$) of Low income and Aid flow from UN agencies (US$) of Bangladesh?
Your response must be concise. 9.53e+07. In the year 1978, what is the difference between the Aid flow from UN agencies (US$) of Low income and Aid flow from UN agencies (US$) of Gambia, The?
Your answer should be compact. 1.07e+08. In the year 1978, what is the difference between the Aid flow from UN agencies (US$) in Bangladesh and Aid flow from UN agencies (US$) in Gambia, The?
Ensure brevity in your answer.  1.15e+07. In the year 1979, what is the difference between the Aid flow from UN agencies (US$) of Least developed countries and Aid flow from UN agencies (US$) of Low income?
Your answer should be very brief. 3.34e+07. In the year 1979, what is the difference between the Aid flow from UN agencies (US$) in Least developed countries and Aid flow from UN agencies (US$) in Bangladesh?
Offer a terse response. 1.56e+08. In the year 1979, what is the difference between the Aid flow from UN agencies (US$) of Least developed countries and Aid flow from UN agencies (US$) of Gambia, The?
Ensure brevity in your answer.  1.68e+08. In the year 1979, what is the difference between the Aid flow from UN agencies (US$) of Low income and Aid flow from UN agencies (US$) of Bangladesh?
Offer a very short reply. 1.23e+08. In the year 1979, what is the difference between the Aid flow from UN agencies (US$) in Low income and Aid flow from UN agencies (US$) in Gambia, The?
Provide a succinct answer. 1.35e+08. In the year 1979, what is the difference between the Aid flow from UN agencies (US$) in Bangladesh and Aid flow from UN agencies (US$) in Gambia, The?
Offer a terse response. 1.16e+07. In the year 1980, what is the difference between the Aid flow from UN agencies (US$) of Least developed countries and Aid flow from UN agencies (US$) of Low income?
Keep it short and to the point. 4.77e+07. In the year 1980, what is the difference between the Aid flow from UN agencies (US$) of Least developed countries and Aid flow from UN agencies (US$) of Bangladesh?
Your response must be concise. 2.17e+08. In the year 1980, what is the difference between the Aid flow from UN agencies (US$) of Least developed countries and Aid flow from UN agencies (US$) of Gambia, The?
Offer a very short reply. 2.34e+08. In the year 1980, what is the difference between the Aid flow from UN agencies (US$) in Low income and Aid flow from UN agencies (US$) in Bangladesh?
Provide a short and direct response. 1.70e+08. In the year 1980, what is the difference between the Aid flow from UN agencies (US$) in Low income and Aid flow from UN agencies (US$) in Gambia, The?
Make the answer very short. 1.86e+08. In the year 1980, what is the difference between the Aid flow from UN agencies (US$) in Bangladesh and Aid flow from UN agencies (US$) in Gambia, The?
Give a very brief answer. 1.66e+07. In the year 1981, what is the difference between the Aid flow from UN agencies (US$) of Least developed countries and Aid flow from UN agencies (US$) of Low income?
Offer a terse response. 7.45e+07. In the year 1981, what is the difference between the Aid flow from UN agencies (US$) in Least developed countries and Aid flow from UN agencies (US$) in Bangladesh?
Give a very brief answer. 3.02e+08. In the year 1981, what is the difference between the Aid flow from UN agencies (US$) in Least developed countries and Aid flow from UN agencies (US$) in Gambia, The?
Offer a terse response. 3.22e+08. In the year 1981, what is the difference between the Aid flow from UN agencies (US$) in Low income and Aid flow from UN agencies (US$) in Bangladesh?
Your answer should be very brief. 2.28e+08. In the year 1981, what is the difference between the Aid flow from UN agencies (US$) in Low income and Aid flow from UN agencies (US$) in Gambia, The?
Provide a succinct answer. 2.48e+08. In the year 1981, what is the difference between the Aid flow from UN agencies (US$) in Bangladesh and Aid flow from UN agencies (US$) in Gambia, The?
Provide a short and direct response. 1.97e+07. In the year 1982, what is the difference between the Aid flow from UN agencies (US$) of Least developed countries and Aid flow from UN agencies (US$) of Low income?
Your answer should be compact. 5.42e+07. In the year 1982, what is the difference between the Aid flow from UN agencies (US$) in Least developed countries and Aid flow from UN agencies (US$) in Bangladesh?
Keep it short and to the point. 2.61e+08. In the year 1982, what is the difference between the Aid flow from UN agencies (US$) of Least developed countries and Aid flow from UN agencies (US$) of Gambia, The?
Your response must be concise. 2.78e+08. In the year 1982, what is the difference between the Aid flow from UN agencies (US$) in Low income and Aid flow from UN agencies (US$) in Bangladesh?
Keep it short and to the point. 2.07e+08. In the year 1982, what is the difference between the Aid flow from UN agencies (US$) of Low income and Aid flow from UN agencies (US$) of Gambia, The?
Ensure brevity in your answer.  2.24e+08. In the year 1982, what is the difference between the Aid flow from UN agencies (US$) of Bangladesh and Aid flow from UN agencies (US$) of Gambia, The?
Provide a short and direct response. 1.70e+07. In the year 1983, what is the difference between the Aid flow from UN agencies (US$) of Least developed countries and Aid flow from UN agencies (US$) of Low income?
Make the answer very short. 4.64e+07. In the year 1983, what is the difference between the Aid flow from UN agencies (US$) in Least developed countries and Aid flow from UN agencies (US$) in Bangladesh?
Give a very brief answer. 2.13e+08. In the year 1983, what is the difference between the Aid flow from UN agencies (US$) in Least developed countries and Aid flow from UN agencies (US$) in Gambia, The?
Offer a terse response. 2.34e+08. In the year 1983, what is the difference between the Aid flow from UN agencies (US$) in Low income and Aid flow from UN agencies (US$) in Bangladesh?
Your response must be concise. 1.66e+08. In the year 1983, what is the difference between the Aid flow from UN agencies (US$) of Low income and Aid flow from UN agencies (US$) of Gambia, The?
Keep it short and to the point. 1.88e+08. In the year 1983, what is the difference between the Aid flow from UN agencies (US$) of Bangladesh and Aid flow from UN agencies (US$) of Gambia, The?
Your response must be concise. 2.14e+07. In the year 1984, what is the difference between the Aid flow from UN agencies (US$) in Least developed countries and Aid flow from UN agencies (US$) in Low income?
Your answer should be compact. 4.18e+07. In the year 1984, what is the difference between the Aid flow from UN agencies (US$) in Least developed countries and Aid flow from UN agencies (US$) in Bangladesh?
Offer a terse response. 2.09e+08. In the year 1984, what is the difference between the Aid flow from UN agencies (US$) of Least developed countries and Aid flow from UN agencies (US$) of Gambia, The?
Keep it short and to the point. 2.32e+08. In the year 1984, what is the difference between the Aid flow from UN agencies (US$) of Low income and Aid flow from UN agencies (US$) of Bangladesh?
Offer a terse response. 1.67e+08. In the year 1984, what is the difference between the Aid flow from UN agencies (US$) in Low income and Aid flow from UN agencies (US$) in Gambia, The?
Your answer should be compact. 1.90e+08. In the year 1984, what is the difference between the Aid flow from UN agencies (US$) in Bangladesh and Aid flow from UN agencies (US$) in Gambia, The?
Provide a short and direct response. 2.29e+07. What is the ratio of the Aid flow from UN agencies (US$) in Least developed countries in 1977 to that in 1978?
Make the answer very short. 0.79. What is the ratio of the Aid flow from UN agencies (US$) of Low income in 1977 to that in 1978?
Ensure brevity in your answer.  0.75. What is the ratio of the Aid flow from UN agencies (US$) of Bangladesh in 1977 to that in 1978?
Your answer should be compact. 0.52. What is the ratio of the Aid flow from UN agencies (US$) in Gambia, The in 1977 to that in 1978?
Provide a succinct answer. 0.35. What is the ratio of the Aid flow from UN agencies (US$) in Least developed countries in 1977 to that in 1979?
Offer a very short reply. 0.63. What is the ratio of the Aid flow from UN agencies (US$) of Low income in 1977 to that in 1979?
Give a very brief answer. 0.6. What is the ratio of the Aid flow from UN agencies (US$) in Bangladesh in 1977 to that in 1979?
Give a very brief answer. 0.52. What is the ratio of the Aid flow from UN agencies (US$) in Gambia, The in 1977 to that in 1979?
Give a very brief answer. 0.35. What is the ratio of the Aid flow from UN agencies (US$) in Least developed countries in 1977 to that in 1980?
Keep it short and to the point. 0.45. What is the ratio of the Aid flow from UN agencies (US$) in Low income in 1977 to that in 1980?
Your answer should be very brief. 0.43. What is the ratio of the Aid flow from UN agencies (US$) of Bangladesh in 1977 to that in 1980?
Keep it short and to the point. 0.37. What is the ratio of the Aid flow from UN agencies (US$) of Gambia, The in 1977 to that in 1980?
Your answer should be compact. 0.29. What is the ratio of the Aid flow from UN agencies (US$) in Least developed countries in 1977 to that in 1981?
Your answer should be compact. 0.33. What is the ratio of the Aid flow from UN agencies (US$) in Low income in 1977 to that in 1981?
Keep it short and to the point. 0.33. What is the ratio of the Aid flow from UN agencies (US$) in Bangladesh in 1977 to that in 1981?
Keep it short and to the point. 0.3. What is the ratio of the Aid flow from UN agencies (US$) in Gambia, The in 1977 to that in 1981?
Offer a terse response. 0.19. What is the ratio of the Aid flow from UN agencies (US$) of Least developed countries in 1977 to that in 1982?
Your answer should be very brief. 0.38. What is the ratio of the Aid flow from UN agencies (US$) of Low income in 1977 to that in 1982?
Give a very brief answer. 0.36. What is the ratio of the Aid flow from UN agencies (US$) of Bangladesh in 1977 to that in 1982?
Offer a terse response. 0.32. What is the ratio of the Aid flow from UN agencies (US$) in Gambia, The in 1977 to that in 1982?
Offer a terse response. 0.14. What is the ratio of the Aid flow from UN agencies (US$) in Least developed countries in 1977 to that in 1983?
Your response must be concise. 0.45. What is the ratio of the Aid flow from UN agencies (US$) in Low income in 1977 to that in 1983?
Keep it short and to the point. 0.43. What is the ratio of the Aid flow from UN agencies (US$) of Bangladesh in 1977 to that in 1983?
Keep it short and to the point. 0.28. What is the ratio of the Aid flow from UN agencies (US$) in Gambia, The in 1977 to that in 1983?
Keep it short and to the point. 0.21. What is the ratio of the Aid flow from UN agencies (US$) of Least developed countries in 1977 to that in 1984?
Ensure brevity in your answer.  0.45. What is the ratio of the Aid flow from UN agencies (US$) in Low income in 1977 to that in 1984?
Provide a succinct answer. 0.42. What is the ratio of the Aid flow from UN agencies (US$) of Bangladesh in 1977 to that in 1984?
Provide a short and direct response. 0.27. What is the ratio of the Aid flow from UN agencies (US$) of Gambia, The in 1977 to that in 1984?
Give a very brief answer. 0.21. What is the ratio of the Aid flow from UN agencies (US$) of Least developed countries in 1978 to that in 1979?
Make the answer very short. 0.79. What is the ratio of the Aid flow from UN agencies (US$) of Low income in 1978 to that in 1979?
Provide a short and direct response. 0.8. What is the ratio of the Aid flow from UN agencies (US$) in Bangladesh in 1978 to that in 1979?
Offer a terse response. 1. What is the ratio of the Aid flow from UN agencies (US$) of Gambia, The in 1978 to that in 1979?
Keep it short and to the point. 1.01. What is the ratio of the Aid flow from UN agencies (US$) of Least developed countries in 1978 to that in 1980?
Provide a short and direct response. 0.57. What is the ratio of the Aid flow from UN agencies (US$) of Low income in 1978 to that in 1980?
Your answer should be compact. 0.58. What is the ratio of the Aid flow from UN agencies (US$) of Bangladesh in 1978 to that in 1980?
Your response must be concise. 0.71. What is the ratio of the Aid flow from UN agencies (US$) in Gambia, The in 1978 to that in 1980?
Give a very brief answer. 0.83. What is the ratio of the Aid flow from UN agencies (US$) in Least developed countries in 1978 to that in 1981?
Ensure brevity in your answer.  0.41. What is the ratio of the Aid flow from UN agencies (US$) of Low income in 1978 to that in 1981?
Give a very brief answer. 0.43. What is the ratio of the Aid flow from UN agencies (US$) in Bangladesh in 1978 to that in 1981?
Provide a succinct answer. 0.58. What is the ratio of the Aid flow from UN agencies (US$) in Gambia, The in 1978 to that in 1981?
Your answer should be very brief. 0.55. What is the ratio of the Aid flow from UN agencies (US$) in Least developed countries in 1978 to that in 1982?
Ensure brevity in your answer.  0.48. What is the ratio of the Aid flow from UN agencies (US$) of Low income in 1978 to that in 1982?
Your response must be concise. 0.48. What is the ratio of the Aid flow from UN agencies (US$) in Bangladesh in 1978 to that in 1982?
Offer a terse response. 0.62. What is the ratio of the Aid flow from UN agencies (US$) in Gambia, The in 1978 to that in 1982?
Your response must be concise. 0.41. What is the ratio of the Aid flow from UN agencies (US$) in Least developed countries in 1978 to that in 1983?
Provide a succinct answer. 0.57. What is the ratio of the Aid flow from UN agencies (US$) of Low income in 1978 to that in 1983?
Ensure brevity in your answer.  0.57. What is the ratio of the Aid flow from UN agencies (US$) of Bangladesh in 1978 to that in 1983?
Provide a succinct answer. 0.54. What is the ratio of the Aid flow from UN agencies (US$) in Gambia, The in 1978 to that in 1983?
Your response must be concise. 0.59. What is the ratio of the Aid flow from UN agencies (US$) in Least developed countries in 1978 to that in 1984?
Your answer should be very brief. 0.58. What is the ratio of the Aid flow from UN agencies (US$) of Low income in 1978 to that in 1984?
Offer a terse response. 0.56. What is the ratio of the Aid flow from UN agencies (US$) of Bangladesh in 1978 to that in 1984?
Provide a succinct answer. 0.51. What is the ratio of the Aid flow from UN agencies (US$) in Gambia, The in 1978 to that in 1984?
Give a very brief answer. 0.61. What is the ratio of the Aid flow from UN agencies (US$) in Least developed countries in 1979 to that in 1980?
Make the answer very short. 0.72. What is the ratio of the Aid flow from UN agencies (US$) in Low income in 1979 to that in 1980?
Provide a short and direct response. 0.72. What is the ratio of the Aid flow from UN agencies (US$) in Bangladesh in 1979 to that in 1980?
Make the answer very short. 0.71. What is the ratio of the Aid flow from UN agencies (US$) of Gambia, The in 1979 to that in 1980?
Make the answer very short. 0.82. What is the ratio of the Aid flow from UN agencies (US$) in Least developed countries in 1979 to that in 1981?
Your response must be concise. 0.52. What is the ratio of the Aid flow from UN agencies (US$) in Low income in 1979 to that in 1981?
Keep it short and to the point. 0.54. What is the ratio of the Aid flow from UN agencies (US$) in Bangladesh in 1979 to that in 1981?
Provide a short and direct response. 0.58. What is the ratio of the Aid flow from UN agencies (US$) in Gambia, The in 1979 to that in 1981?
Your response must be concise. 0.54. What is the ratio of the Aid flow from UN agencies (US$) of Least developed countries in 1979 to that in 1982?
Give a very brief answer. 0.6. What is the ratio of the Aid flow from UN agencies (US$) of Low income in 1979 to that in 1982?
Provide a succinct answer. 0.6. What is the ratio of the Aid flow from UN agencies (US$) of Bangladesh in 1979 to that in 1982?
Provide a short and direct response. 0.62. What is the ratio of the Aid flow from UN agencies (US$) of Gambia, The in 1979 to that in 1982?
Ensure brevity in your answer.  0.4. What is the ratio of the Aid flow from UN agencies (US$) of Least developed countries in 1979 to that in 1983?
Your answer should be very brief. 0.72. What is the ratio of the Aid flow from UN agencies (US$) in Low income in 1979 to that in 1983?
Your answer should be compact. 0.72. What is the ratio of the Aid flow from UN agencies (US$) in Bangladesh in 1979 to that in 1983?
Provide a short and direct response. 0.55. What is the ratio of the Aid flow from UN agencies (US$) in Gambia, The in 1979 to that in 1983?
Provide a short and direct response. 0.59. What is the ratio of the Aid flow from UN agencies (US$) of Least developed countries in 1979 to that in 1984?
Make the answer very short. 0.72. What is the ratio of the Aid flow from UN agencies (US$) in Low income in 1979 to that in 1984?
Provide a short and direct response. 0.71. What is the ratio of the Aid flow from UN agencies (US$) of Bangladesh in 1979 to that in 1984?
Provide a succinct answer. 0.52. What is the ratio of the Aid flow from UN agencies (US$) of Gambia, The in 1979 to that in 1984?
Your response must be concise. 0.61. What is the ratio of the Aid flow from UN agencies (US$) in Least developed countries in 1980 to that in 1981?
Provide a succinct answer. 0.73. What is the ratio of the Aid flow from UN agencies (US$) in Low income in 1980 to that in 1981?
Give a very brief answer. 0.75. What is the ratio of the Aid flow from UN agencies (US$) of Bangladesh in 1980 to that in 1981?
Your answer should be compact. 0.81. What is the ratio of the Aid flow from UN agencies (US$) in Gambia, The in 1980 to that in 1981?
Your response must be concise. 0.66. What is the ratio of the Aid flow from UN agencies (US$) in Least developed countries in 1980 to that in 1982?
Your response must be concise. 0.84. What is the ratio of the Aid flow from UN agencies (US$) of Low income in 1980 to that in 1982?
Provide a short and direct response. 0.82. What is the ratio of the Aid flow from UN agencies (US$) of Bangladesh in 1980 to that in 1982?
Your answer should be compact. 0.87. What is the ratio of the Aid flow from UN agencies (US$) in Gambia, The in 1980 to that in 1982?
Provide a short and direct response. 0.49. What is the ratio of the Aid flow from UN agencies (US$) in Least developed countries in 1980 to that in 1983?
Your answer should be very brief. 0.99. What is the ratio of the Aid flow from UN agencies (US$) of Low income in 1980 to that in 1983?
Ensure brevity in your answer.  0.99. What is the ratio of the Aid flow from UN agencies (US$) in Bangladesh in 1980 to that in 1983?
Your response must be concise. 0.77. What is the ratio of the Aid flow from UN agencies (US$) in Gambia, The in 1980 to that in 1983?
Provide a succinct answer. 0.72. What is the ratio of the Aid flow from UN agencies (US$) of Least developed countries in 1980 to that in 1984?
Offer a very short reply. 1.01. What is the ratio of the Aid flow from UN agencies (US$) of Low income in 1980 to that in 1984?
Your answer should be compact. 0.98. What is the ratio of the Aid flow from UN agencies (US$) of Bangladesh in 1980 to that in 1984?
Keep it short and to the point. 0.72. What is the ratio of the Aid flow from UN agencies (US$) of Gambia, The in 1980 to that in 1984?
Your response must be concise. 0.74. What is the ratio of the Aid flow from UN agencies (US$) in Least developed countries in 1981 to that in 1982?
Your answer should be very brief. 1.15. What is the ratio of the Aid flow from UN agencies (US$) of Low income in 1981 to that in 1982?
Your response must be concise. 1.1. What is the ratio of the Aid flow from UN agencies (US$) in Bangladesh in 1981 to that in 1982?
Your answer should be compact. 1.07. What is the ratio of the Aid flow from UN agencies (US$) of Gambia, The in 1981 to that in 1982?
Your response must be concise. 0.74. What is the ratio of the Aid flow from UN agencies (US$) in Least developed countries in 1981 to that in 1983?
Make the answer very short. 1.37. What is the ratio of the Aid flow from UN agencies (US$) in Low income in 1981 to that in 1983?
Your answer should be compact. 1.32. What is the ratio of the Aid flow from UN agencies (US$) in Bangladesh in 1981 to that in 1983?
Your response must be concise. 0.94. What is the ratio of the Aid flow from UN agencies (US$) in Gambia, The in 1981 to that in 1983?
Keep it short and to the point. 1.09. What is the ratio of the Aid flow from UN agencies (US$) of Least developed countries in 1981 to that in 1984?
Your answer should be compact. 1.39. What is the ratio of the Aid flow from UN agencies (US$) of Low income in 1981 to that in 1984?
Your answer should be very brief. 1.3. What is the ratio of the Aid flow from UN agencies (US$) in Bangladesh in 1981 to that in 1984?
Ensure brevity in your answer.  0.89. What is the ratio of the Aid flow from UN agencies (US$) of Gambia, The in 1981 to that in 1984?
Your response must be concise. 1.12. What is the ratio of the Aid flow from UN agencies (US$) in Least developed countries in 1982 to that in 1983?
Provide a succinct answer. 1.19. What is the ratio of the Aid flow from UN agencies (US$) of Low income in 1982 to that in 1983?
Ensure brevity in your answer.  1.2. What is the ratio of the Aid flow from UN agencies (US$) of Bangladesh in 1982 to that in 1983?
Make the answer very short. 0.88. What is the ratio of the Aid flow from UN agencies (US$) of Gambia, The in 1982 to that in 1983?
Ensure brevity in your answer.  1.46. What is the ratio of the Aid flow from UN agencies (US$) of Least developed countries in 1982 to that in 1984?
Offer a very short reply. 1.2. What is the ratio of the Aid flow from UN agencies (US$) of Low income in 1982 to that in 1984?
Offer a terse response. 1.19. What is the ratio of the Aid flow from UN agencies (US$) in Bangladesh in 1982 to that in 1984?
Offer a very short reply. 0.83. What is the ratio of the Aid flow from UN agencies (US$) of Gambia, The in 1982 to that in 1984?
Keep it short and to the point. 1.5. What is the ratio of the Aid flow from UN agencies (US$) in Least developed countries in 1983 to that in 1984?
Provide a short and direct response. 1.01. What is the ratio of the Aid flow from UN agencies (US$) of Low income in 1983 to that in 1984?
Ensure brevity in your answer.  0.99. What is the ratio of the Aid flow from UN agencies (US$) of Bangladesh in 1983 to that in 1984?
Your response must be concise. 0.94. What is the ratio of the Aid flow from UN agencies (US$) of Gambia, The in 1983 to that in 1984?
Provide a short and direct response. 1.03. What is the difference between the highest and the second highest Aid flow from UN agencies (US$) of Least developed countries?
Give a very brief answer. 4.29e+07. What is the difference between the highest and the second highest Aid flow from UN agencies (US$) of Low income?
Provide a succinct answer. 2.25e+07. What is the difference between the highest and the second highest Aid flow from UN agencies (US$) in Bangladesh?
Provide a short and direct response. 1.48e+06. What is the difference between the highest and the second highest Aid flow from UN agencies (US$) in Gambia, The?
Make the answer very short. 1.17e+06. What is the difference between the highest and the lowest Aid flow from UN agencies (US$) of Least developed countries?
Offer a very short reply. 2.19e+08. What is the difference between the highest and the lowest Aid flow from UN agencies (US$) in Low income?
Keep it short and to the point. 1.69e+08. What is the difference between the highest and the lowest Aid flow from UN agencies (US$) of Bangladesh?
Your response must be concise. 1.90e+07. What is the difference between the highest and the lowest Aid flow from UN agencies (US$) in Gambia, The?
Provide a short and direct response. 3.92e+06. 